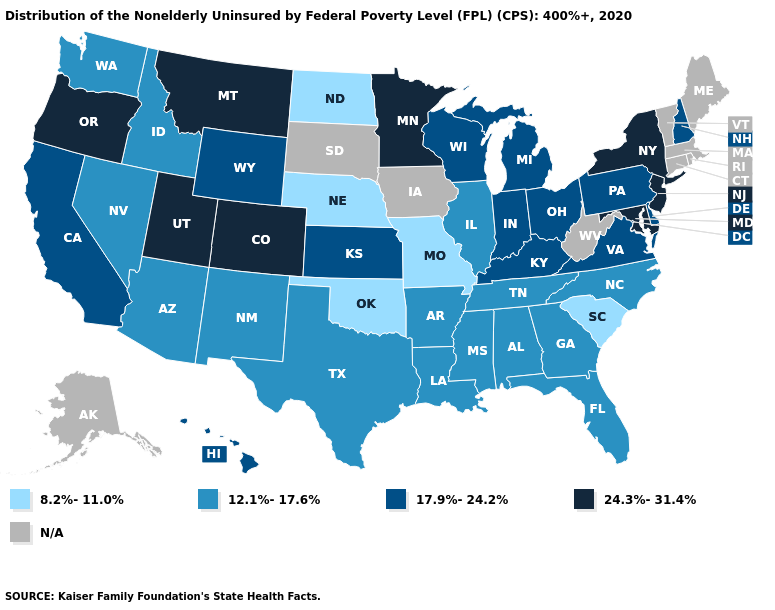What is the lowest value in the USA?
Give a very brief answer. 8.2%-11.0%. Name the states that have a value in the range 24.3%-31.4%?
Answer briefly. Colorado, Maryland, Minnesota, Montana, New Jersey, New York, Oregon, Utah. Name the states that have a value in the range N/A?
Be succinct. Alaska, Connecticut, Iowa, Maine, Massachusetts, Rhode Island, South Dakota, Vermont, West Virginia. What is the value of North Carolina?
Keep it brief. 12.1%-17.6%. Among the states that border Connecticut , which have the highest value?
Answer briefly. New York. What is the value of Maine?
Answer briefly. N/A. What is the value of Illinois?
Keep it brief. 12.1%-17.6%. What is the lowest value in states that border South Carolina?
Write a very short answer. 12.1%-17.6%. What is the value of Ohio?
Concise answer only. 17.9%-24.2%. Name the states that have a value in the range 24.3%-31.4%?
Be succinct. Colorado, Maryland, Minnesota, Montana, New Jersey, New York, Oregon, Utah. Does the first symbol in the legend represent the smallest category?
Write a very short answer. Yes. Does the map have missing data?
Give a very brief answer. Yes. Does North Dakota have the lowest value in the MidWest?
Quick response, please. Yes. What is the highest value in states that border Maryland?
Give a very brief answer. 17.9%-24.2%. 